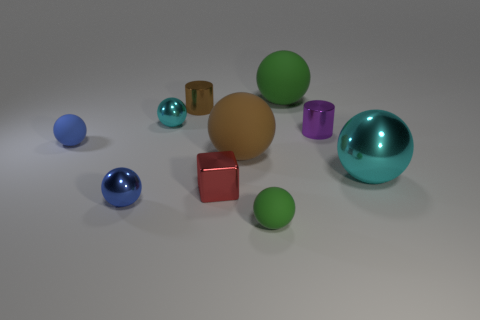There is a small thing that is the same color as the big metal thing; what is its material?
Your answer should be very brief. Metal. What number of cyan objects are big shiny objects or tiny metallic balls?
Offer a terse response. 2. What is the material of the big sphere that is behind the small blue rubber sphere?
Offer a terse response. Rubber. Does the tiny blue sphere in front of the red block have the same material as the red block?
Keep it short and to the point. Yes. The tiny red shiny object is what shape?
Give a very brief answer. Cube. What number of brown balls are left of the cyan thing that is on the left side of the big matte object behind the brown shiny object?
Your answer should be compact. 0. What number of other objects are the same material as the big green sphere?
Your answer should be very brief. 3. What material is the brown cylinder that is the same size as the blue matte ball?
Provide a short and direct response. Metal. Does the tiny cylinder that is behind the tiny purple object have the same color as the tiny matte object right of the tiny blue shiny ball?
Provide a succinct answer. No. Are there any large red rubber objects that have the same shape as the small blue rubber object?
Provide a short and direct response. No. 